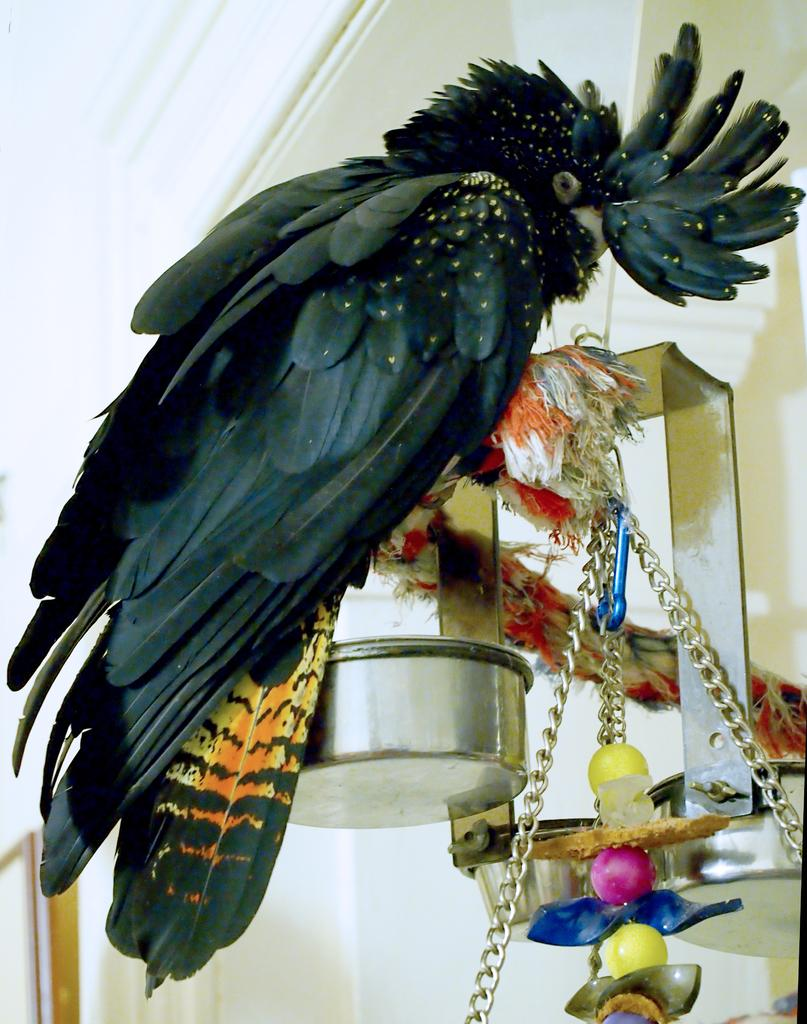What type of animal can be seen in the image? There is a bird in the image. What objects are present in the image besides the bird? There are bowls and chains visible in the image. What can be seen in the background of the image? There is a wall in the background of the image. How many lizards can be seen in the image? There are no lizards present in the image. 